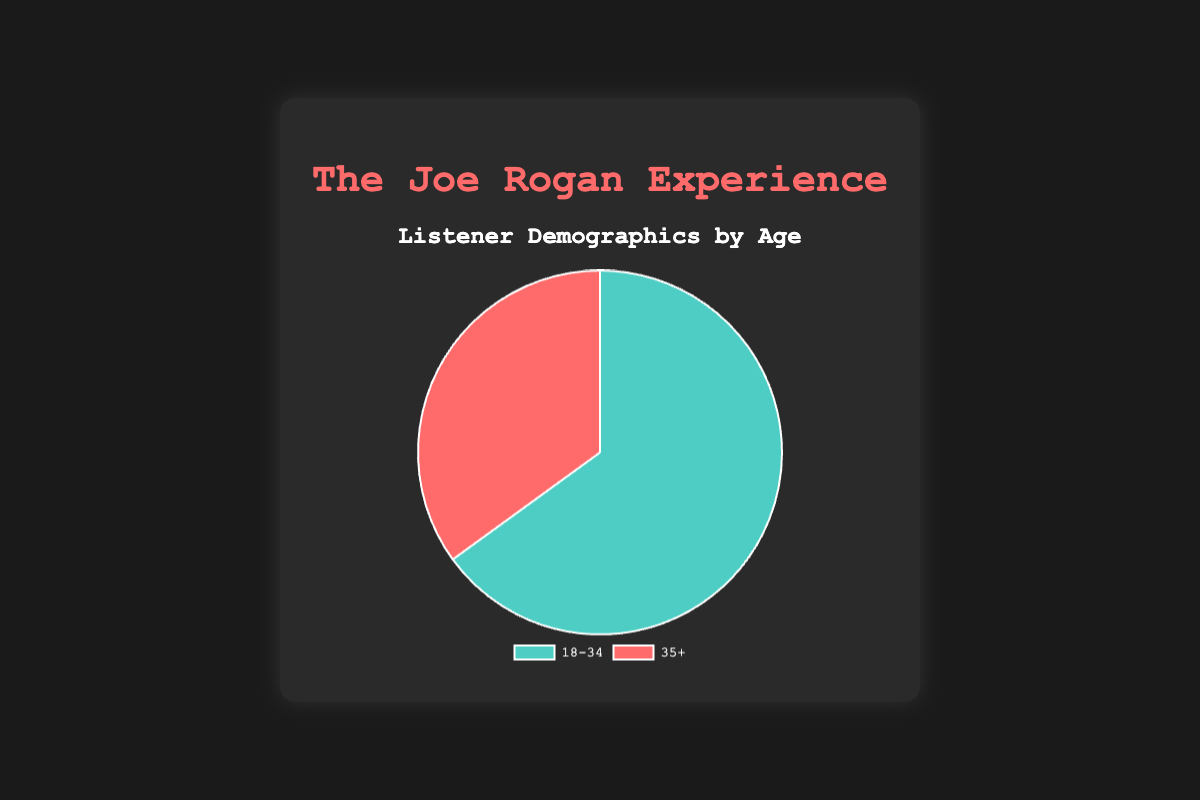What percentage of listeners are aged 18-34? The pie chart visually represents the percentage of listeners. By looking at the segment labeled "18-34", we see that it occupies 65% of the chart.
Answer: 65% Which age group has the higher percentage of listeners? By comparing the sizes of the segments in the pie chart, the "18-34" segment is larger than the "35+" segment, indicating a higher percentage.
Answer: 18-34 What is the difference in percentage between the two age groups? To find the difference, subtract the percentage of the "35+" group from the "18-34" group: 65% - 35% = 30%.
Answer: 30% If the total number of listeners is 100,000, how many listeners are aged 35+? Calculate 35% of 100,000: 0.35 * 100,000 = 35,000.
Answer: 35,000 What is the ratio of listeners aged 18-34 to those aged 35+? To find the ratio, divide the percentage of 18-34 listeners by the percentage of 35+ listeners: 65 / 35 = 1.86.
Answer: 1.86 What would be the combined percentage of listeners if we merged both age groups into one? The sum of the percentages of both age groups is 65% + 35% = 100%.
Answer: 100% Which segment is represented in red? The pie chart's legend indicates that the segment labeled "35+" is colored red.
Answer: 35+ Which age group has the segment colored in green? The legend shows that the "18-34" segment is colored green.
Answer: 18-34 